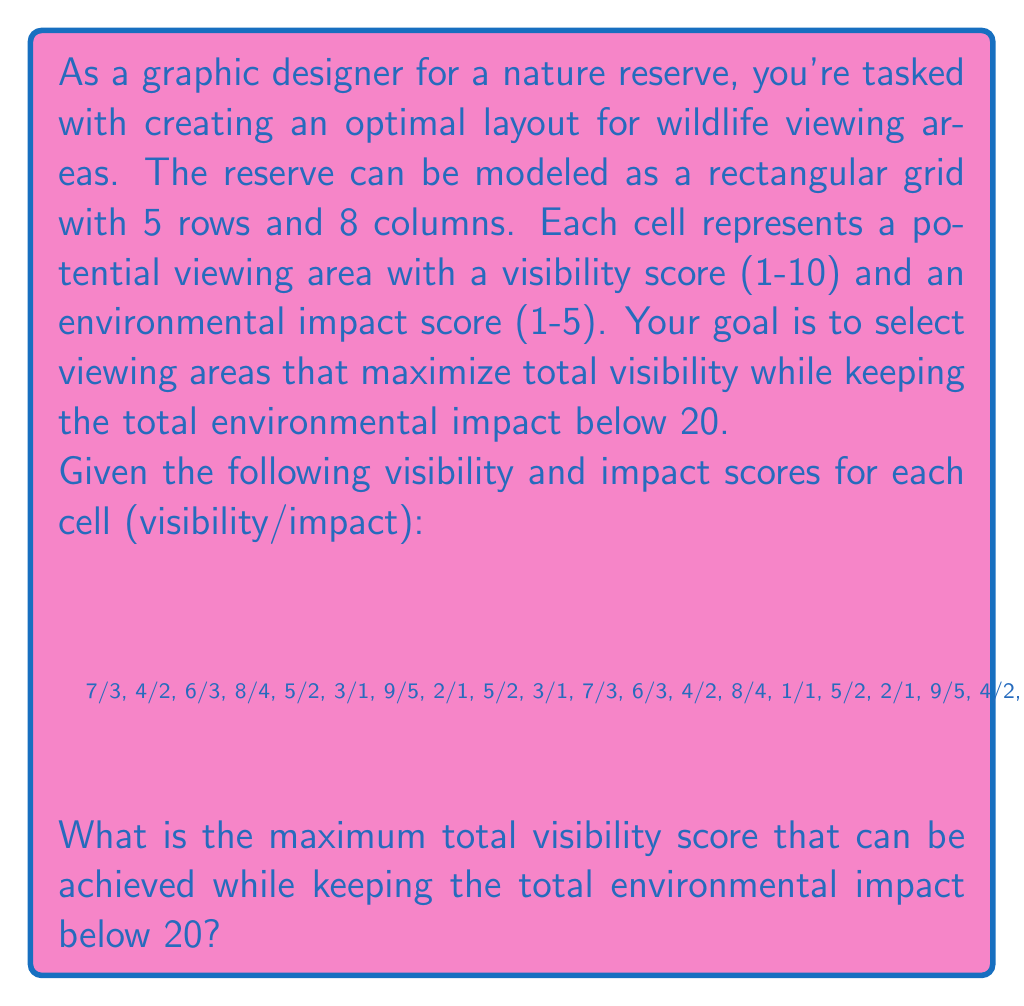Give your solution to this math problem. To solve this problem, we can use a greedy approach with a slight modification to account for the environmental impact constraint. Here's a step-by-step explanation:

1. Calculate the visibility-to-impact ratio for each cell:
   Ratio = Visibility Score / Impact Score

2. Sort the cells in descending order based on their visibility-to-impact ratio.

3. Starting from the highest ratio, select cells and add their visibility and impact scores to running totals.

4. Stop when adding the next cell would cause the total impact to exceed 20.

5. Sum up the visibility scores of the selected cells.

Let's apply this method:

1. Calculate ratios and sort (showing top 10):
   9/5 (1.8), 8/4 (2.0), 9/5 (1.8), 8/4 (2.0), 8/4 (2.0), 7/3 (2.33), 7/3 (2.33), 7/3 (2.33), 6/3 (2.0), 6/3 (2.0)

2. Select cells in order:
   7/3 (2.33) - Visibility: 7, Impact: 3, Total Impact: 3
   7/3 (2.33) - Visibility: 14, Impact: 6, Total Impact: 6
   7/3 (2.33) - Visibility: 21, Impact: 9, Total Impact: 9
   8/4 (2.0) - Visibility: 29, Impact: 13, Total Impact: 13
   8/4 (2.0) - Visibility: 37, Impact: 17, Total Impact: 17

3. The next highest ratio cell (8/4) would bring the total impact to 21, exceeding our limit of 20.

4. Therefore, we stop here and sum up the visibility scores of the selected cells.

The maximum total visibility score achievable while keeping the total environmental impact below 20 is 37.
Answer: 37 